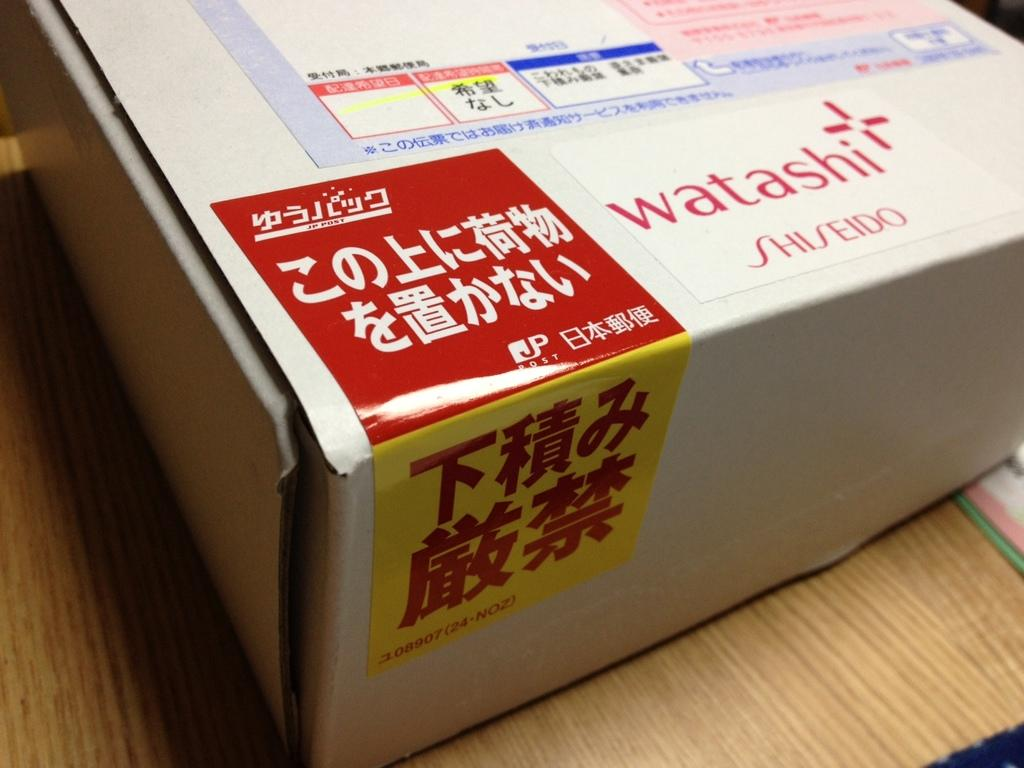<image>
Create a compact narrative representing the image presented. A cardboard box with the brand logo "watashi" labelled on it. 